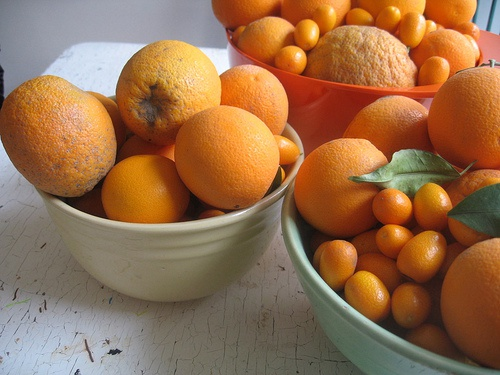Describe the objects in this image and their specific colors. I can see orange in gray, brown, maroon, and orange tones, bowl in gray tones, orange in gray, brown, orange, and maroon tones, orange in gray, brown, and orange tones, and bowl in gray, darkgray, and black tones in this image. 